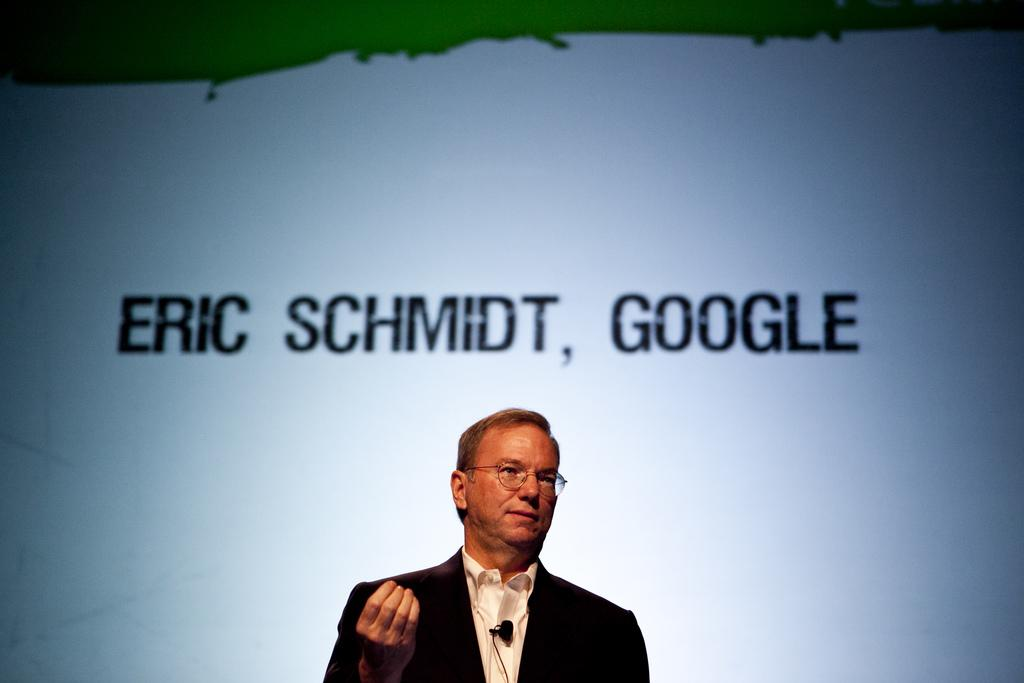Who is the main subject in the image? There is a man in the center of the image. What is the man wearing? The man is wearing a black coat and a white shirt. What can be seen in the background of the image? There is a screen in the background of the image. What is written on the screen? There is text written on the screen. How does the man use magic to solve his troubles in the image? There is no indication of magic or troubles in the image; it simply shows a man wearing a black coat and a white shirt with a screen in the background. 